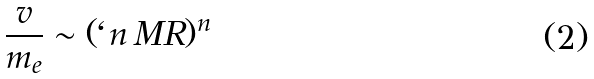Convert formula to latex. <formula><loc_0><loc_0><loc_500><loc_500>\frac { v } { m _ { e } } \sim ( \ell n \, M R ) ^ { n }</formula> 